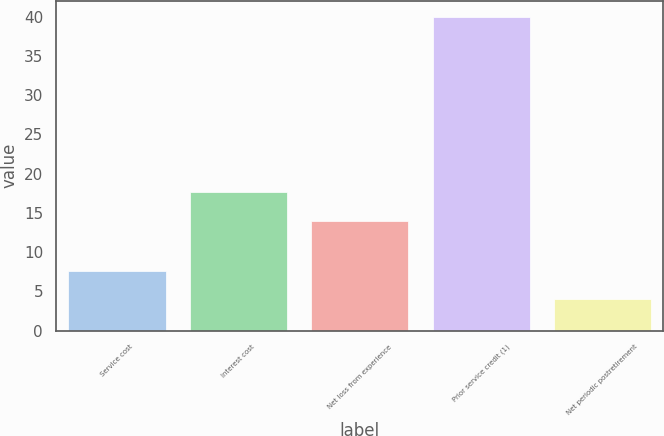Convert chart. <chart><loc_0><loc_0><loc_500><loc_500><bar_chart><fcel>Service cost<fcel>Interest cost<fcel>Net loss from experience<fcel>Prior service credit (1)<fcel>Net periodic postretirement<nl><fcel>7.6<fcel>17.6<fcel>14<fcel>40<fcel>4<nl></chart> 